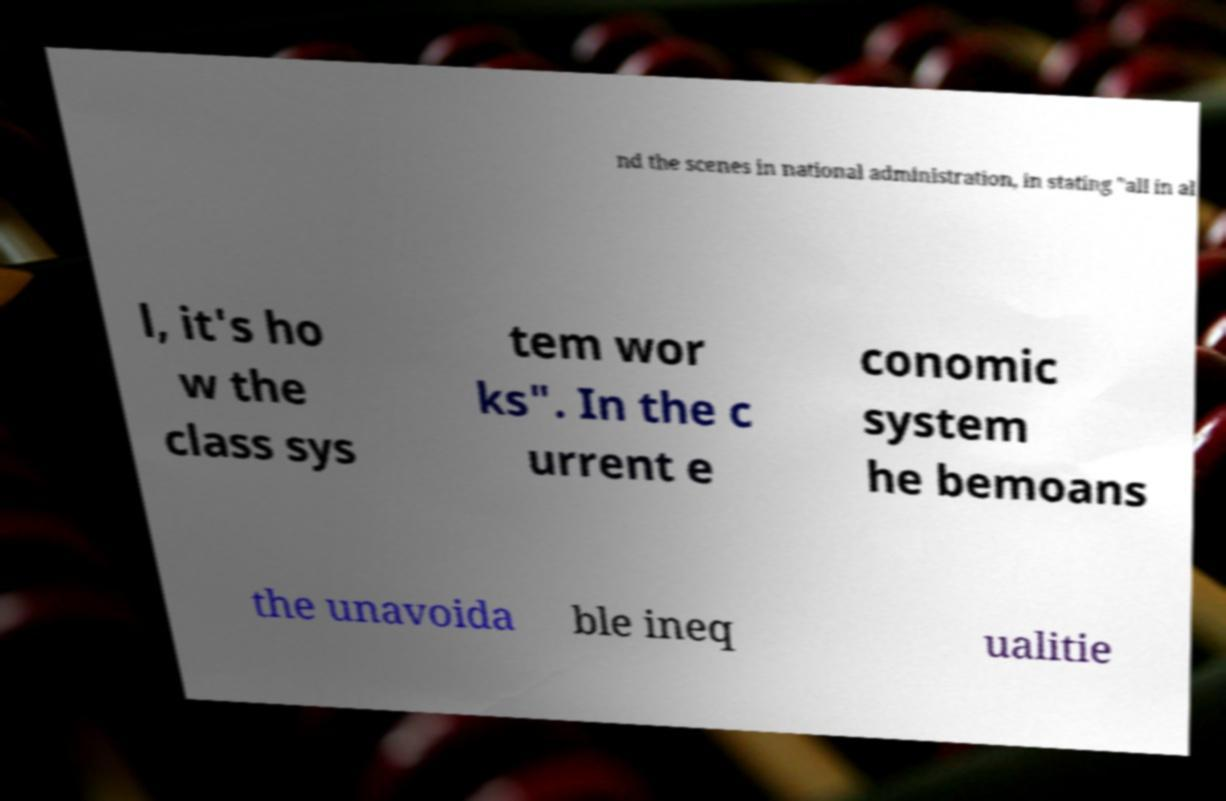Can you read and provide the text displayed in the image?This photo seems to have some interesting text. Can you extract and type it out for me? nd the scenes in national administration, in stating "all in al l, it's ho w the class sys tem wor ks". In the c urrent e conomic system he bemoans the unavoida ble ineq ualitie 